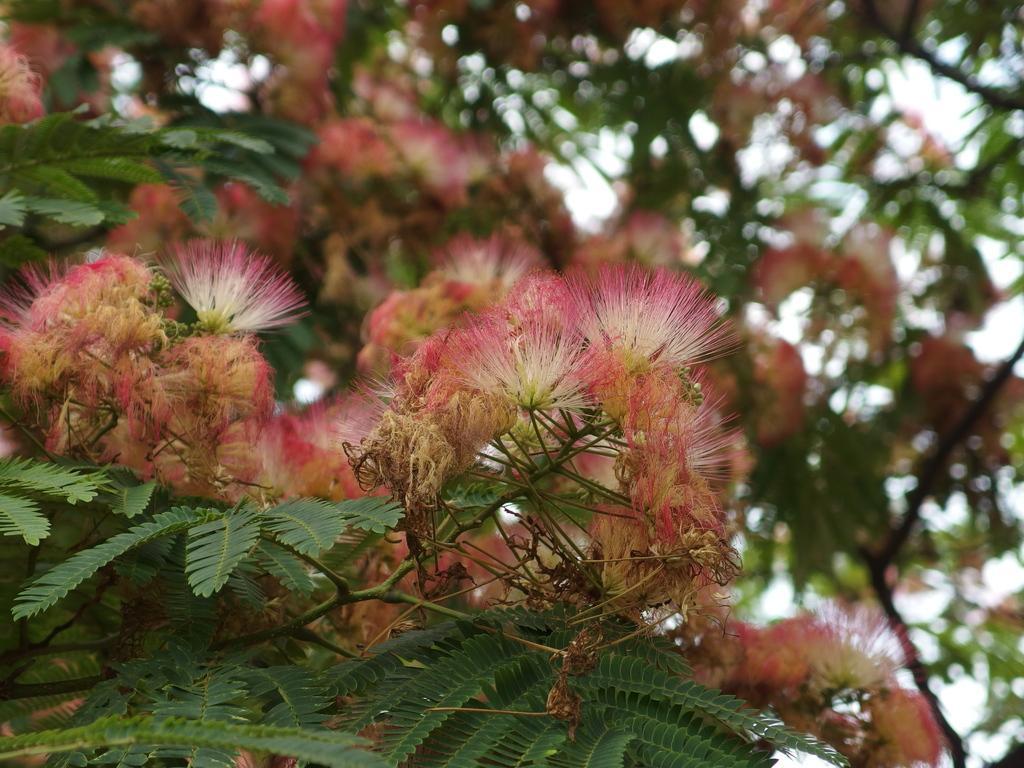Describe this image in one or two sentences. In this image we can see flowers, leaves and stems and there is a sky in the background. 